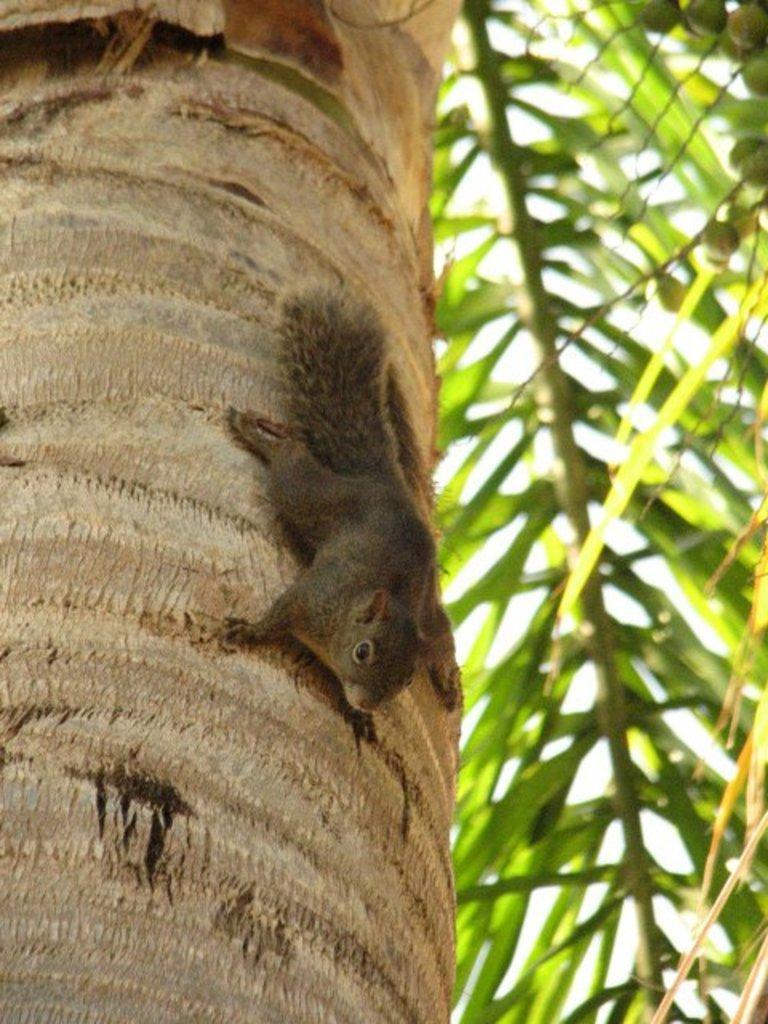How would you summarize this image in a sentence or two? To the left side there is a tree trunk with squirrel on it. And to the right side of the image there are coconut leaves. 